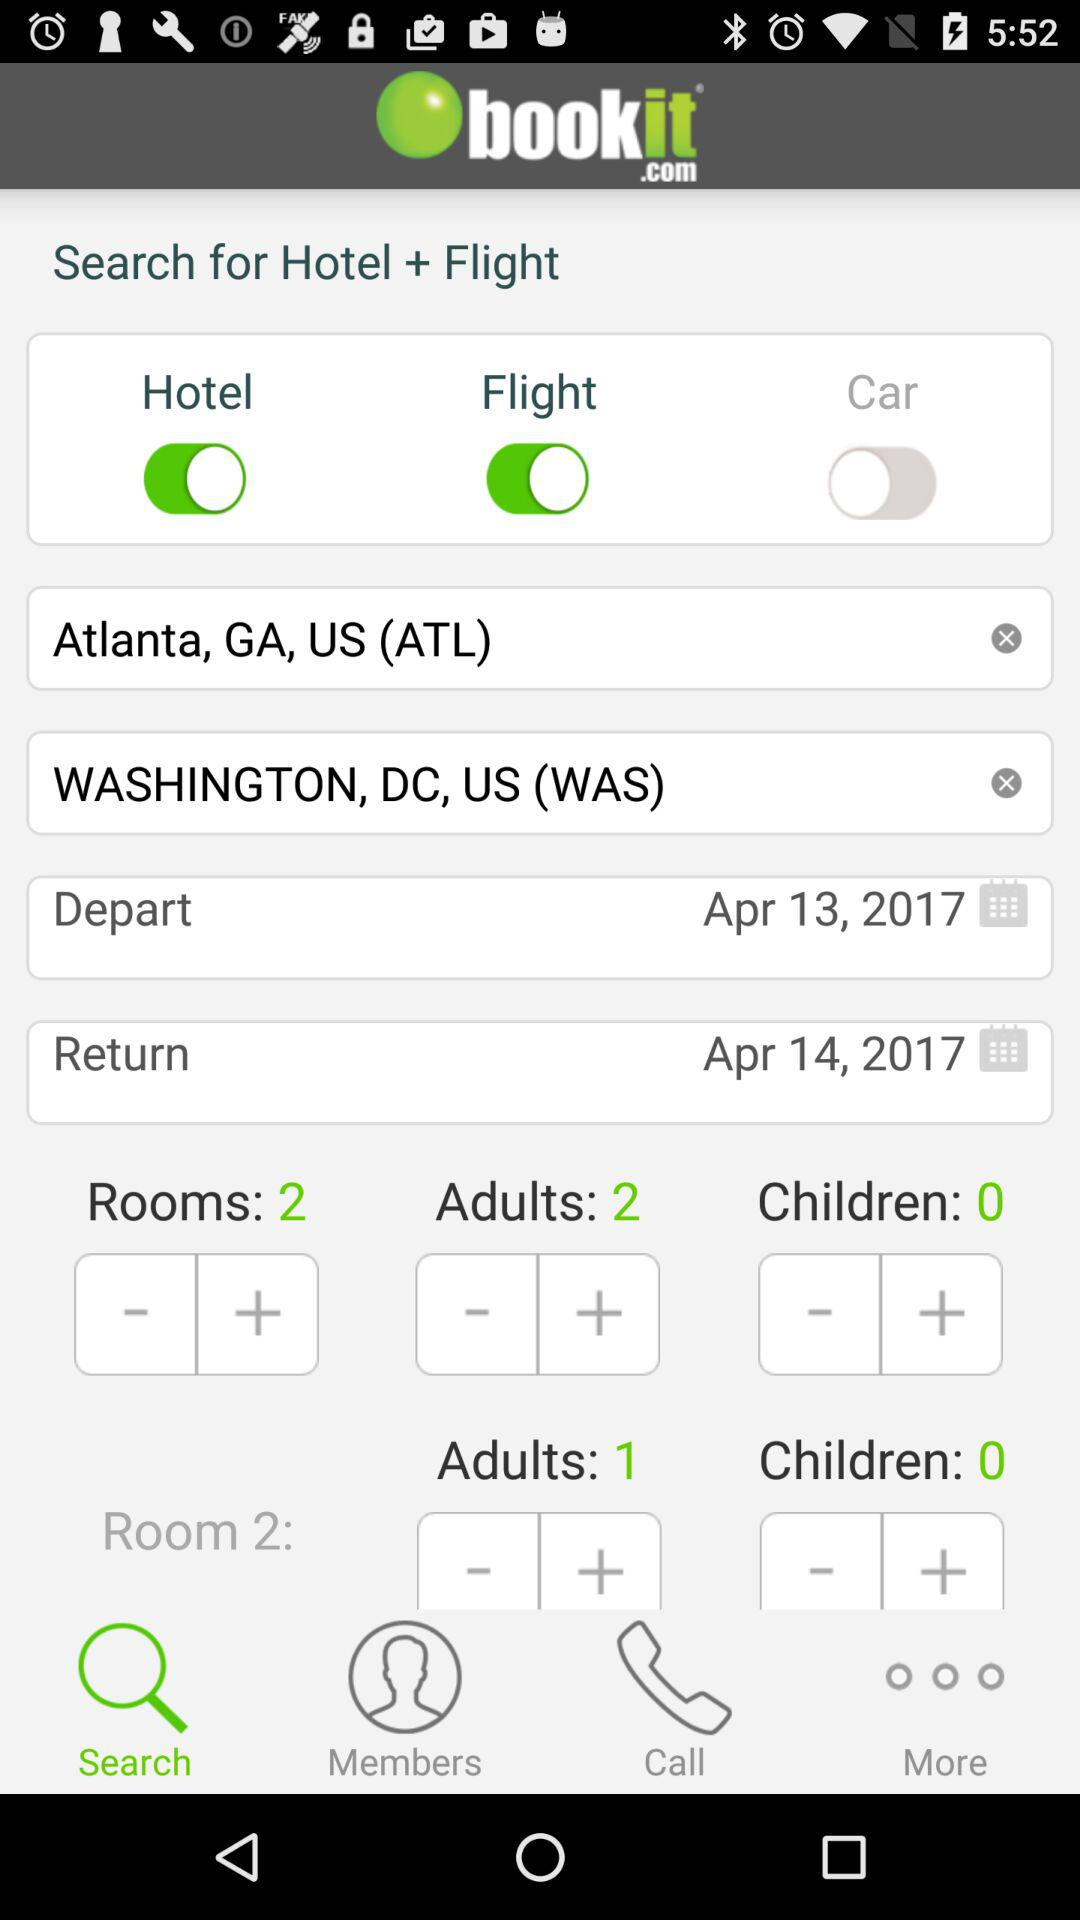Which tab is selected? The selected tab is "Search". 